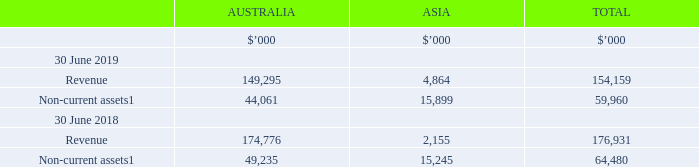2.1 Segment information
Segment information is based on the information that management uses to make decisions about operating matters and allows users to review operations through the eyes of management. We present our reportable segments and measure our segment results on continuing operations basis, i.e. the same basis as our internal management reporting structure.
We have four reportable segments which offer a service that includes comparison, purchase support and lead referrals across:
• Health (private health insurance),
• Life and General Insurance,
• Energy and Telecommunications, and
• Other, predominately offering financial service products including home loans in Australia and Asia.
In the current year, unallocated corporate costs include costs associated with the business restructure and other one-off transactions.
1 Non-current assets other than financial instruments and deferred tax assets.
What are the four reportable segments which offer a service that includes comparison, purchase support and lead referrals? Health (private health insurance), life and general insurance, energy and telecommunications, other, predominately offering financial service products including home loans in australia and asia. What do the unalloacated corporate costs include in the current year? Costs associated with the business restructure and other one-off transactions. What is the revenue in Australia in 2019?
Answer scale should be: thousand. 149,295. What is the percentage change in the revenue in Australia from 2018 to 2019?
Answer scale should be: percent. (149,295-174,776)/174,776
Answer: -14.58. What is the percentage change in the revenue in Asia from 2018 to 2019?
Answer scale should be: percent. (4,864-2,155)/2,155
Answer: 125.71. What is the percentage of Australia's non-current assets in the total non-current assets in 2019?
Answer scale should be: percent. 44,061/59,960
Answer: 73.48. 